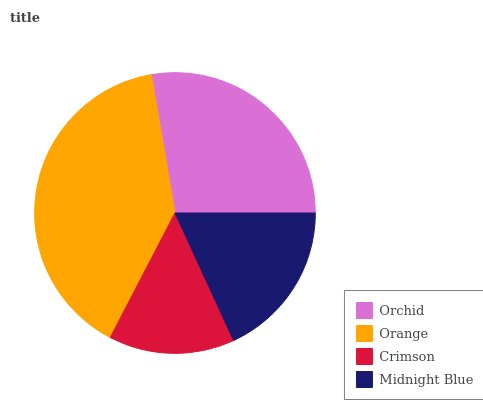Is Crimson the minimum?
Answer yes or no. Yes. Is Orange the maximum?
Answer yes or no. Yes. Is Orange the minimum?
Answer yes or no. No. Is Crimson the maximum?
Answer yes or no. No. Is Orange greater than Crimson?
Answer yes or no. Yes. Is Crimson less than Orange?
Answer yes or no. Yes. Is Crimson greater than Orange?
Answer yes or no. No. Is Orange less than Crimson?
Answer yes or no. No. Is Orchid the high median?
Answer yes or no. Yes. Is Midnight Blue the low median?
Answer yes or no. Yes. Is Midnight Blue the high median?
Answer yes or no. No. Is Orchid the low median?
Answer yes or no. No. 